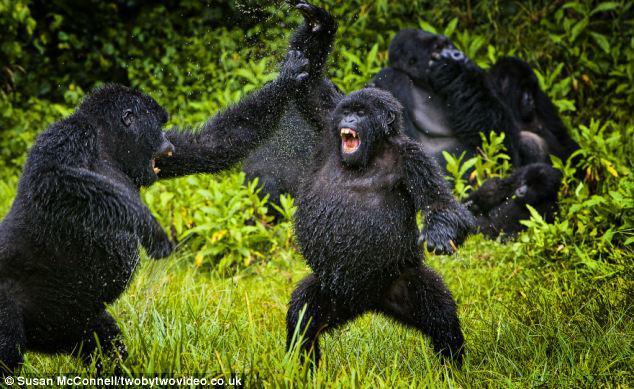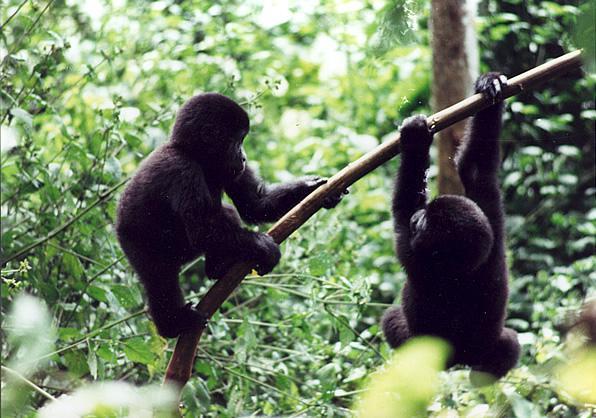The first image is the image on the left, the second image is the image on the right. For the images displayed, is the sentence "There are at most four gorillas." factually correct? Answer yes or no. No. The first image is the image on the left, the second image is the image on the right. Considering the images on both sides, is "On one image, there is a baby gorilla on top of a bigger gorilla." valid? Answer yes or no. No. 